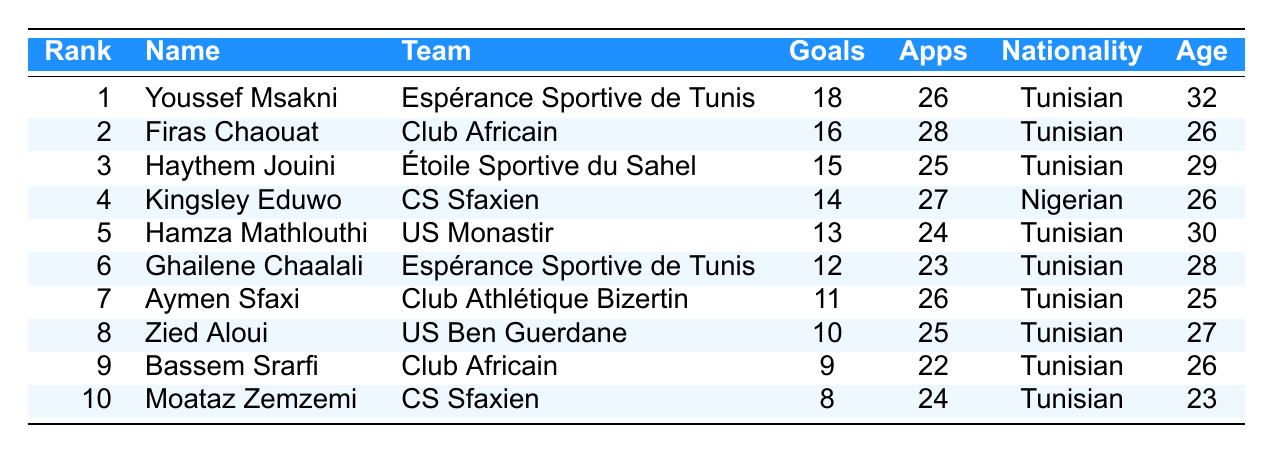What is the highest number of goals scored by a player in the table? The table shows the goal scorers along with their respective goals. The player with the highest goals is Youssef Msakni with 18 goals.
Answer: 18 Who is the youngest goal scorer in the table? To find the youngest player, we look at the ages listed for each player. Moataz Zemzemi is the youngest at 23 years old.
Answer: 23 How many goals did Firas Chaouat score? Firas Chaouat is listed in the table with a goal count of 16.
Answer: 16 Which team has the most players listed in the top goal scorers? By scanning the team column in the table, both Espérance Sportive de Tunis and Club Africain each have 2 players listed.
Answer: Espérance Sportive de Tunis and Club Africain What is the total number of goals scored by the top three players? The top three players are Youssef Msakni with 18 goals, Firas Chaouat with 16 goals, and Haythem Jouini with 15 goals. Adding them gives 18 + 16 + 15 = 49 goals.
Answer: 49 Did any player score 10 goals? Checking the goals column, Zied Aloui scored exactly 10 goals.
Answer: Yes What is the average age of the players in the table? The ages of the players are 32, 26, 29, 26, 30, 28, 25, 27, 26, and 23. Summing these (32 + 26 + 29 + 26 + 30 + 28 + 25 + 27 + 26 + 23 =  8) gives  26. The average is found by dividing the total by the number of players (10), resulting in 26.
Answer: 26 What is the difference in goals scored between the top scorer and the player ranked 10th? The top scorer Youssef Msakni has 18 goals and the 10th ranked Moataz Zemzemi has 8 goals. The difference is 18 - 8 = 10.
Answer: 10 Which nationality has more players in the top 10? Looking at the table, Tunisian players make up 8 out of the 10 listed scorers, while Nigerian players have 2.
Answer: Tunisian List the names of players who scored more than 10 goals. The players with more than 10 goals are Youssef Msakni, Firas Chaouat, Haythem Jouini, Kingsley Eduwo, Hamza Mathlouthi, and Ghailene Chaalali.
Answer: Youssef Msakni, Firas Chaouat, Haythem Jouini, Kingsley Eduwo, Hamza Mathlouthi, Ghailene Chaalali What is the combined number of appearances for the top scorers on the list? Summing the appearances gives 26 + 28 + 25 + 27 + 24 + 23 + 26 + 25 + 22 + 24 =  25.
Answer: 25 